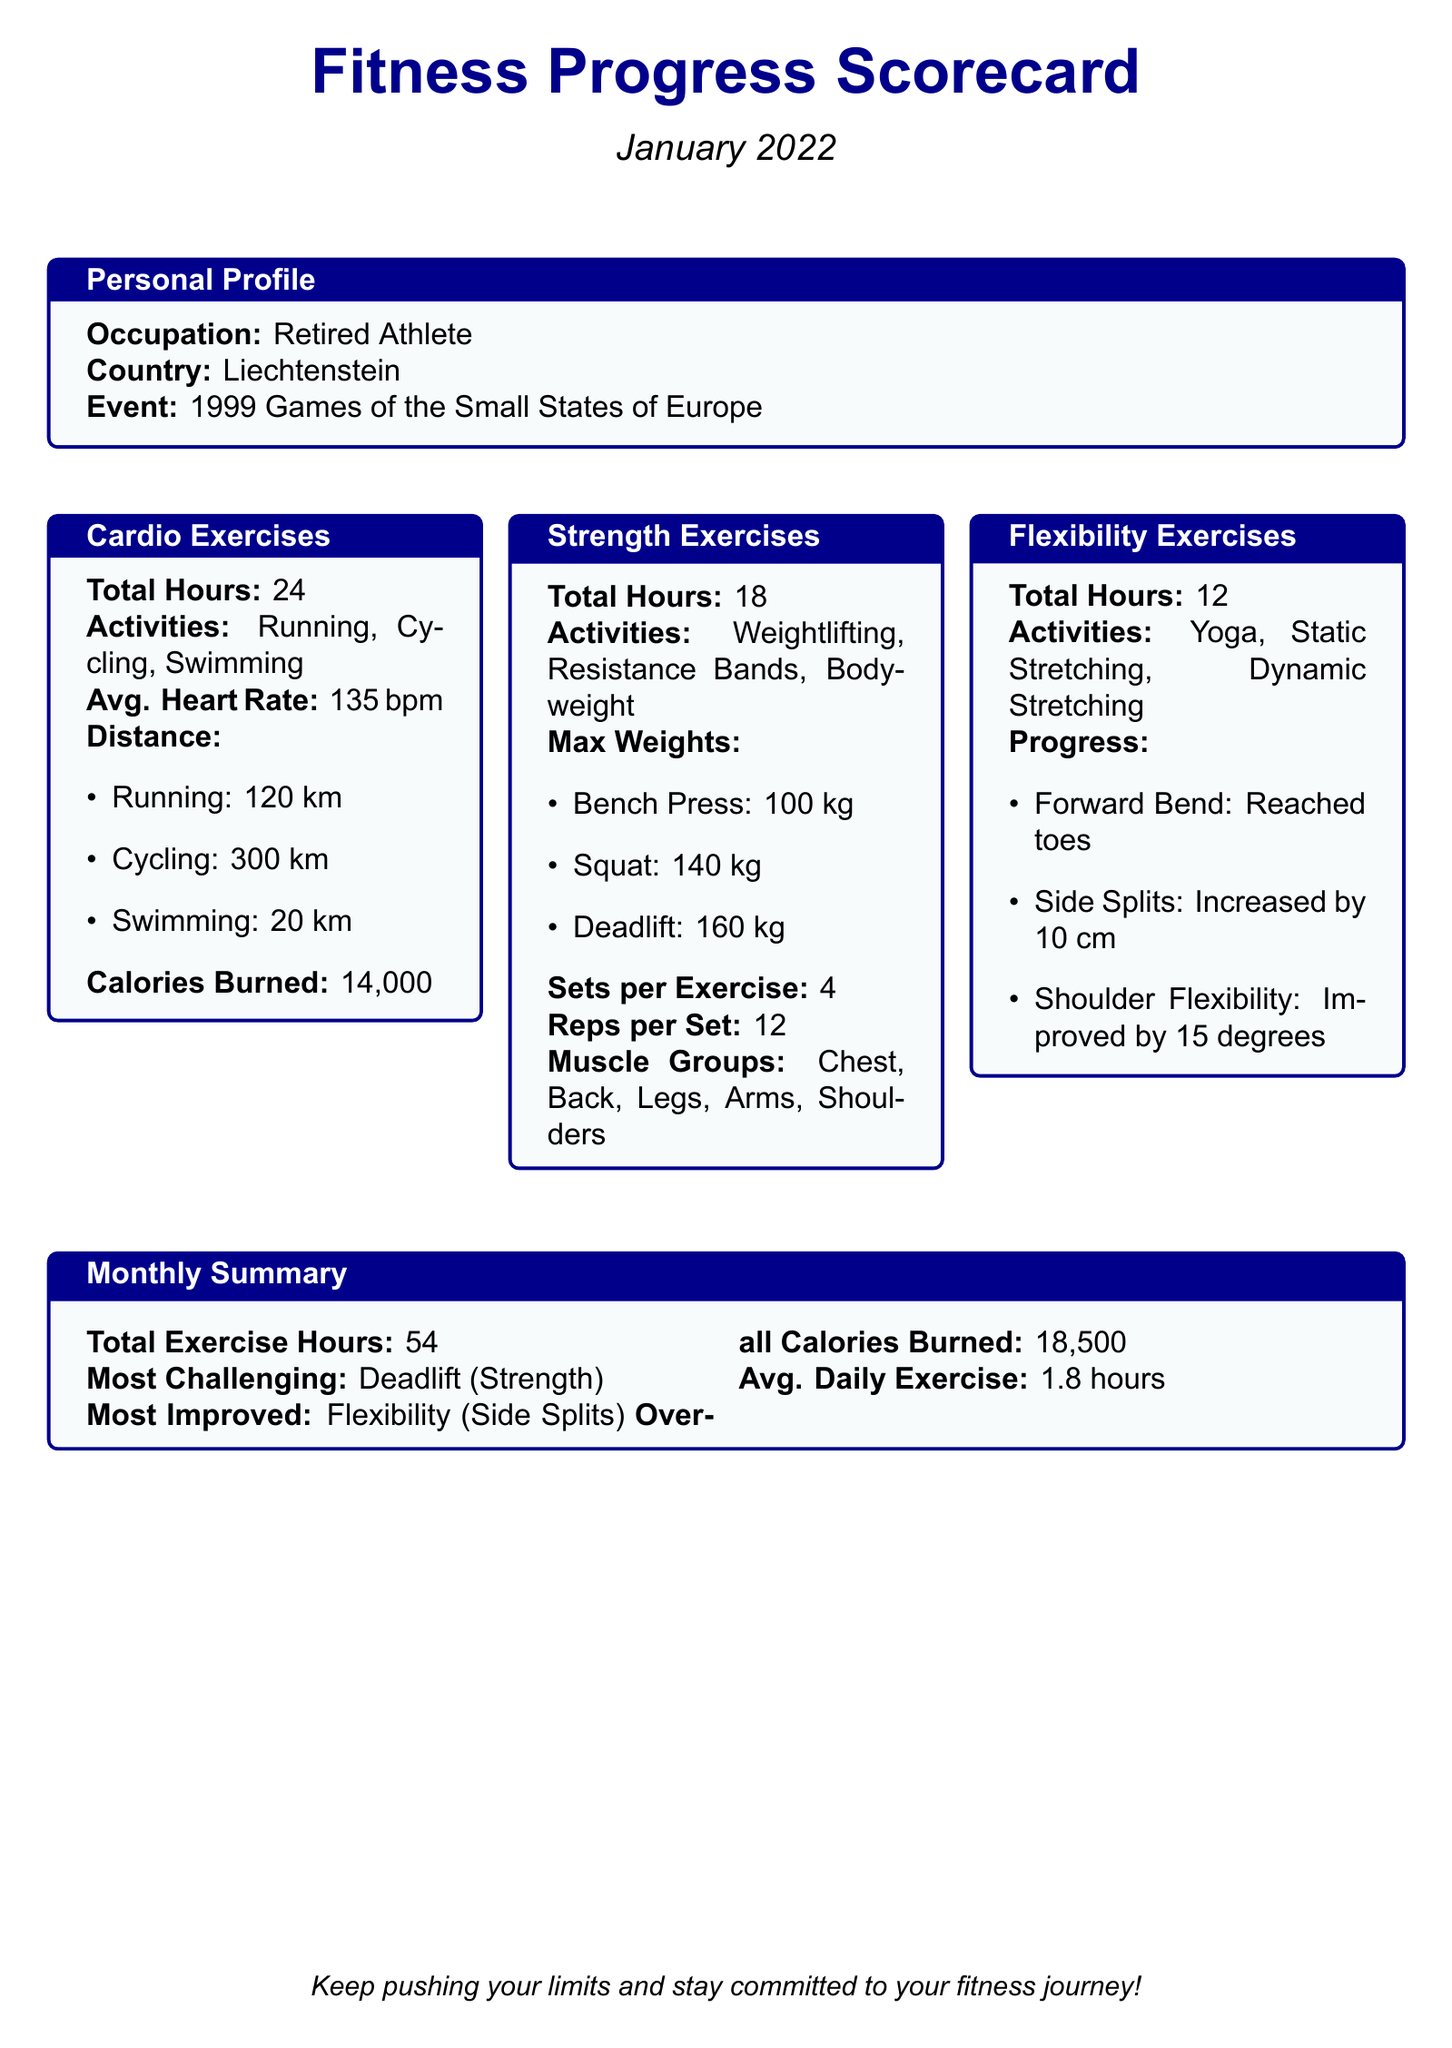What was the total exercise hours for January 2022? The total exercise hours are expressed in the Monthly Summary section of the document as 54 hours.
Answer: 54 How many calories were burned in total? The overall calories burned is provided in the Monthly Summary section of the document as 18,500 calories.
Answer: 18,500 What was the average heart rate during cardio exercises? The average heart rate can be found in the Cardio Exercises section, which states the average heart rate is 135 bpm.
Answer: 135 bpm Which exercise was identified as the most challenging? In the Monthly Summary section, the most challenging exercise is listed as Deadlift.
Answer: Deadlift What is the total number of hours dedicated to flexibility exercises? The total hours for flexibility exercises is found in the Flexibility Exercises section, which shows 12 hours.
Answer: 12 How much did the side splits increase by? The progress of side splits is mentioned in the Flexibility Exercises section, which indicates an increase of 10 cm.
Answer: 10 cm What was the max weight for the squat exercise? The maximum weight for squat exercise is specified in the Strength Exercises section, showing 140 kg.
Answer: 140 kg Which muscle groups were targeted in strength exercises? The targeted muscle groups can be found in the Strength Exercises section, listed as Chest, Back, Legs, Arms, Shoulders.
Answer: Chest, Back, Legs, Arms, Shoulders What was the average daily exercise time? The average daily exercise time is provided in the Monthly Summary as 1.8 hours.
Answer: 1.8 hours 